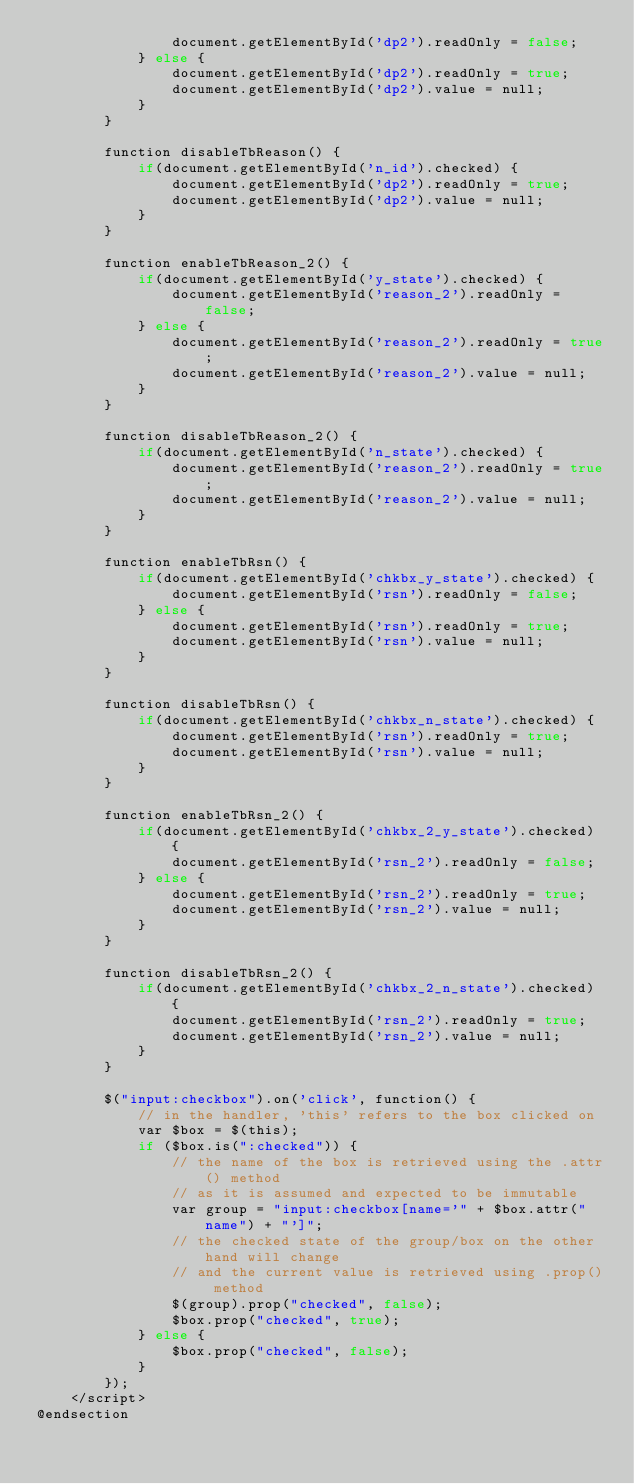<code> <loc_0><loc_0><loc_500><loc_500><_PHP_>				document.getElementById('dp2').readOnly = false;
			} else {
				document.getElementById('dp2').readOnly = true;
				document.getElementById('dp2').value = null;
			}
		}

		function disableTbReason() {
			if(document.getElementById('n_id').checked) {
				document.getElementById('dp2').readOnly = true;
				document.getElementById('dp2').value = null;
			}
		}

		function enableTbReason_2() {
			if(document.getElementById('y_state').checked) {
				document.getElementById('reason_2').readOnly = false;
			} else {
				document.getElementById('reason_2').readOnly = true;
				document.getElementById('reason_2').value = null;
			}
		}

		function disableTbReason_2() {
			if(document.getElementById('n_state').checked) {
				document.getElementById('reason_2').readOnly = true;
				document.getElementById('reason_2').value = null;
			} 
		}

		function enableTbRsn() {
			if(document.getElementById('chkbx_y_state').checked) {
				document.getElementById('rsn').readOnly = false;
			} else {
				document.getElementById('rsn').readOnly = true;
				document.getElementById('rsn').value = null;
			}
		}

		function disableTbRsn() {
			if(document.getElementById('chkbx_n_state').checked) {
				document.getElementById('rsn').readOnly = true;
				document.getElementById('rsn').value = null;
			} 
		}

		function enableTbRsn_2() {
			if(document.getElementById('chkbx_2_y_state').checked) {
				document.getElementById('rsn_2').readOnly = false;
			} else {
				document.getElementById('rsn_2').readOnly = true;
				document.getElementById('rsn_2').value = null;
			}
		}

		function disableTbRsn_2() {
			if(document.getElementById('chkbx_2_n_state').checked) {
				document.getElementById('rsn_2').readOnly = true;
				document.getElementById('rsn_2').value = null;
			} 
		}

		$("input:checkbox").on('click', function() {
			// in the handler, 'this' refers to the box clicked on
			var $box = $(this);
			if ($box.is(":checked")) {
				// the name of the box is retrieved using the .attr() method
				// as it is assumed and expected to be immutable
				var group = "input:checkbox[name='" + $box.attr("name") + "']";
				// the checked state of the group/box on the other hand will change
				// and the current value is retrieved using .prop() method
				$(group).prop("checked", false);
				$box.prop("checked", true);
			} else {
				$box.prop("checked", false);
			}
		});
	</script>
@endsection</code> 